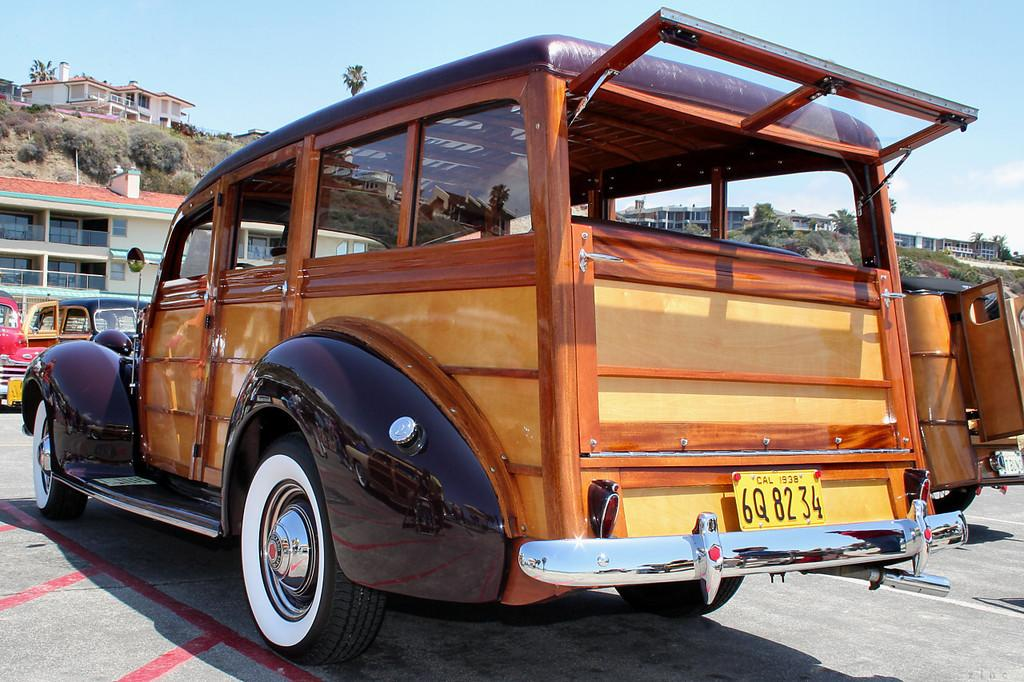What is located in the front of the image? There are vehicles in the front of the image. What can be seen in the background of the image? There are buildings, trees, clouds, and the sky visible in the background of the image. Where is the hall located in the image? There is no hall present in the image. What type of cracker is being eaten by the people in the image? There are no people or crackers present in the image. 